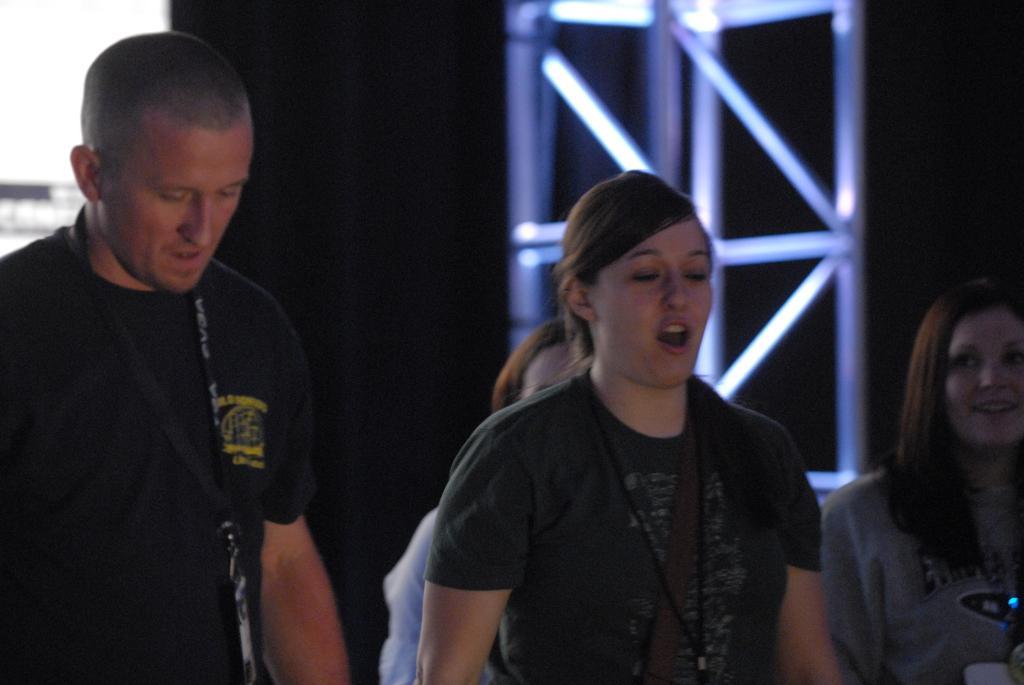How would you summarize this image in a sentence or two? In the foreground, I can see four persons. In the background, I can see metal rods, a wall and a dark color. This image taken, maybe in a hall. 